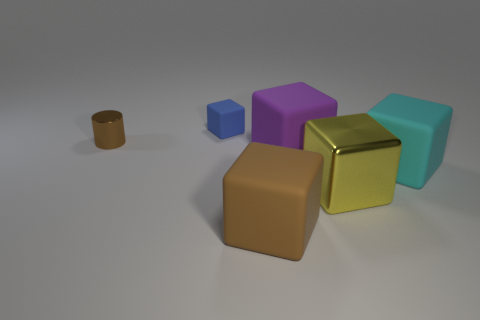Could you tell me about the lighting of this scene? The lighting in the scene appears to be soft and diffuse, coming from the top left direction. There are gentle shadows cast by the objects, indicating a single light source without harsh intensity, which gives the scene a calm and even ambiance. 